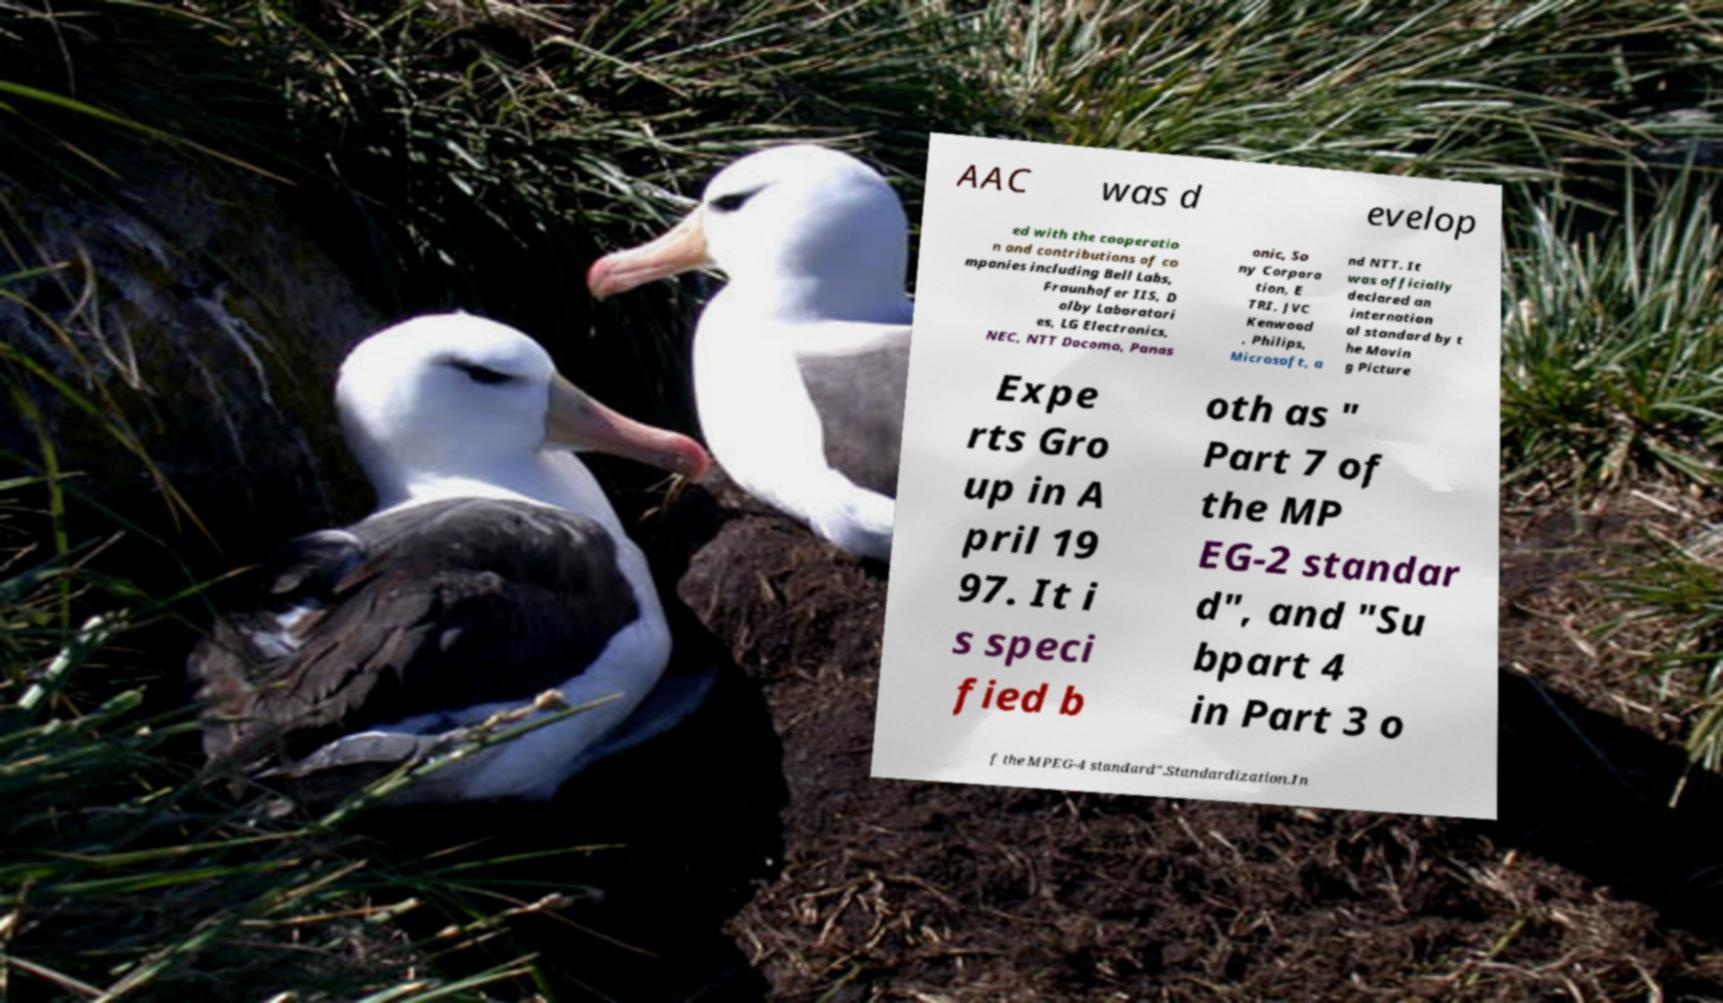Can you read and provide the text displayed in the image?This photo seems to have some interesting text. Can you extract and type it out for me? AAC was d evelop ed with the cooperatio n and contributions of co mpanies including Bell Labs, Fraunhofer IIS, D olby Laboratori es, LG Electronics, NEC, NTT Docomo, Panas onic, So ny Corpora tion, E TRI, JVC Kenwood , Philips, Microsoft, a nd NTT. It was officially declared an internation al standard by t he Movin g Picture Expe rts Gro up in A pril 19 97. It i s speci fied b oth as " Part 7 of the MP EG-2 standar d", and "Su bpart 4 in Part 3 o f the MPEG-4 standard".Standardization.In 